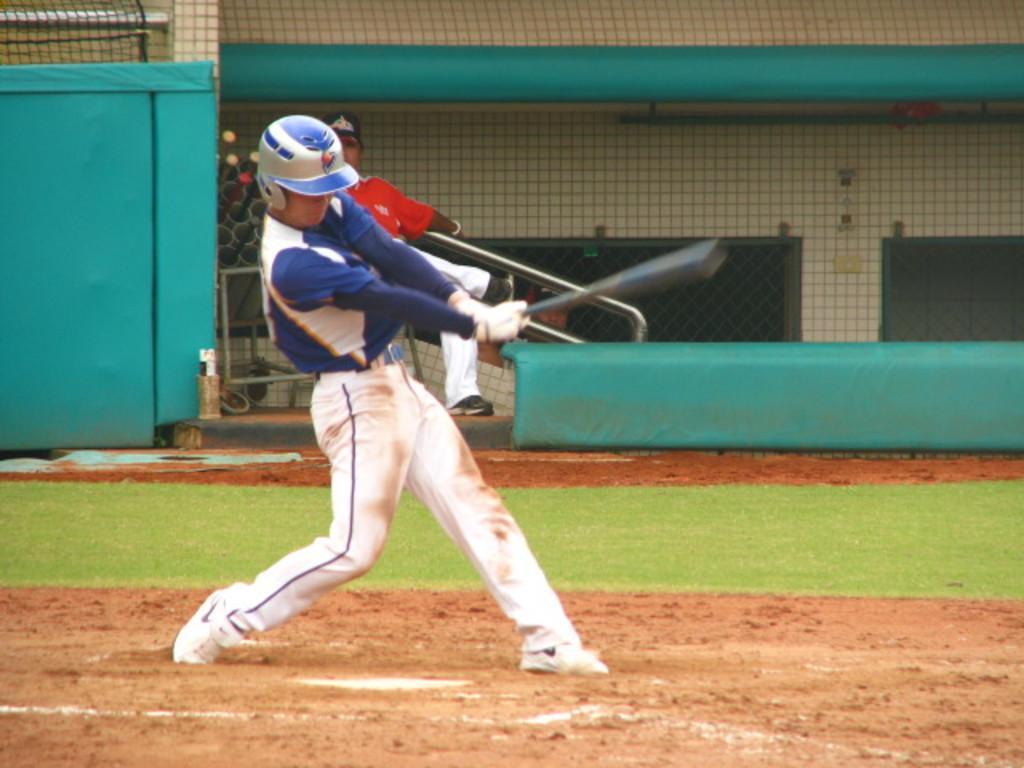Can you describe this image briefly? Here we can see a person playing on the ground. Here we can see grass, mesh, and wall. 